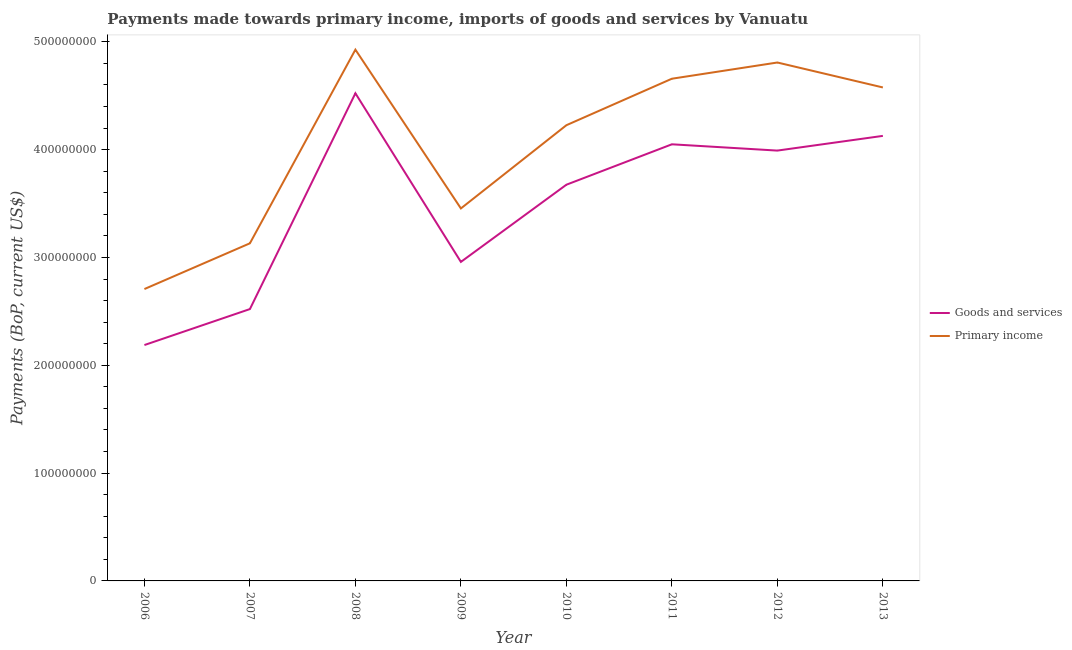Does the line corresponding to payments made towards primary income intersect with the line corresponding to payments made towards goods and services?
Offer a very short reply. No. Is the number of lines equal to the number of legend labels?
Your answer should be very brief. Yes. What is the payments made towards goods and services in 2010?
Ensure brevity in your answer.  3.68e+08. Across all years, what is the maximum payments made towards goods and services?
Make the answer very short. 4.52e+08. Across all years, what is the minimum payments made towards goods and services?
Give a very brief answer. 2.19e+08. In which year was the payments made towards goods and services maximum?
Your response must be concise. 2008. What is the total payments made towards goods and services in the graph?
Offer a very short reply. 2.80e+09. What is the difference between the payments made towards primary income in 2012 and that in 2013?
Offer a very short reply. 2.31e+07. What is the difference between the payments made towards goods and services in 2009 and the payments made towards primary income in 2010?
Provide a short and direct response. -1.27e+08. What is the average payments made towards goods and services per year?
Your response must be concise. 3.50e+08. In the year 2008, what is the difference between the payments made towards goods and services and payments made towards primary income?
Keep it short and to the point. -4.05e+07. In how many years, is the payments made towards goods and services greater than 80000000 US$?
Make the answer very short. 8. What is the ratio of the payments made towards primary income in 2008 to that in 2012?
Ensure brevity in your answer.  1.02. Is the payments made towards primary income in 2010 less than that in 2011?
Your answer should be compact. Yes. What is the difference between the highest and the second highest payments made towards primary income?
Offer a terse response. 1.19e+07. What is the difference between the highest and the lowest payments made towards goods and services?
Ensure brevity in your answer.  2.34e+08. Is the sum of the payments made towards goods and services in 2006 and 2013 greater than the maximum payments made towards primary income across all years?
Your response must be concise. Yes. Does the payments made towards primary income monotonically increase over the years?
Provide a short and direct response. No. Is the payments made towards primary income strictly greater than the payments made towards goods and services over the years?
Your answer should be compact. Yes. Are the values on the major ticks of Y-axis written in scientific E-notation?
Give a very brief answer. No. Where does the legend appear in the graph?
Ensure brevity in your answer.  Center right. How are the legend labels stacked?
Provide a succinct answer. Vertical. What is the title of the graph?
Offer a terse response. Payments made towards primary income, imports of goods and services by Vanuatu. What is the label or title of the X-axis?
Provide a short and direct response. Year. What is the label or title of the Y-axis?
Provide a short and direct response. Payments (BoP, current US$). What is the Payments (BoP, current US$) of Goods and services in 2006?
Make the answer very short. 2.19e+08. What is the Payments (BoP, current US$) in Primary income in 2006?
Make the answer very short. 2.71e+08. What is the Payments (BoP, current US$) of Goods and services in 2007?
Provide a succinct answer. 2.52e+08. What is the Payments (BoP, current US$) in Primary income in 2007?
Your answer should be compact. 3.13e+08. What is the Payments (BoP, current US$) of Goods and services in 2008?
Provide a succinct answer. 4.52e+08. What is the Payments (BoP, current US$) of Primary income in 2008?
Provide a succinct answer. 4.93e+08. What is the Payments (BoP, current US$) of Goods and services in 2009?
Provide a short and direct response. 2.96e+08. What is the Payments (BoP, current US$) of Primary income in 2009?
Ensure brevity in your answer.  3.45e+08. What is the Payments (BoP, current US$) of Goods and services in 2010?
Your answer should be very brief. 3.68e+08. What is the Payments (BoP, current US$) of Primary income in 2010?
Provide a succinct answer. 4.23e+08. What is the Payments (BoP, current US$) in Goods and services in 2011?
Your answer should be compact. 4.05e+08. What is the Payments (BoP, current US$) of Primary income in 2011?
Your answer should be compact. 4.66e+08. What is the Payments (BoP, current US$) of Goods and services in 2012?
Provide a short and direct response. 3.99e+08. What is the Payments (BoP, current US$) in Primary income in 2012?
Provide a succinct answer. 4.81e+08. What is the Payments (BoP, current US$) in Goods and services in 2013?
Provide a succinct answer. 4.13e+08. What is the Payments (BoP, current US$) of Primary income in 2013?
Provide a short and direct response. 4.58e+08. Across all years, what is the maximum Payments (BoP, current US$) in Goods and services?
Give a very brief answer. 4.52e+08. Across all years, what is the maximum Payments (BoP, current US$) of Primary income?
Give a very brief answer. 4.93e+08. Across all years, what is the minimum Payments (BoP, current US$) of Goods and services?
Keep it short and to the point. 2.19e+08. Across all years, what is the minimum Payments (BoP, current US$) in Primary income?
Provide a succinct answer. 2.71e+08. What is the total Payments (BoP, current US$) in Goods and services in the graph?
Keep it short and to the point. 2.80e+09. What is the total Payments (BoP, current US$) of Primary income in the graph?
Offer a very short reply. 3.25e+09. What is the difference between the Payments (BoP, current US$) of Goods and services in 2006 and that in 2007?
Provide a succinct answer. -3.34e+07. What is the difference between the Payments (BoP, current US$) of Primary income in 2006 and that in 2007?
Make the answer very short. -4.24e+07. What is the difference between the Payments (BoP, current US$) of Goods and services in 2006 and that in 2008?
Offer a terse response. -2.34e+08. What is the difference between the Payments (BoP, current US$) of Primary income in 2006 and that in 2008?
Keep it short and to the point. -2.22e+08. What is the difference between the Payments (BoP, current US$) in Goods and services in 2006 and that in 2009?
Your response must be concise. -7.71e+07. What is the difference between the Payments (BoP, current US$) of Primary income in 2006 and that in 2009?
Give a very brief answer. -7.48e+07. What is the difference between the Payments (BoP, current US$) in Goods and services in 2006 and that in 2010?
Give a very brief answer. -1.49e+08. What is the difference between the Payments (BoP, current US$) in Primary income in 2006 and that in 2010?
Your answer should be very brief. -1.52e+08. What is the difference between the Payments (BoP, current US$) of Goods and services in 2006 and that in 2011?
Ensure brevity in your answer.  -1.86e+08. What is the difference between the Payments (BoP, current US$) of Primary income in 2006 and that in 2011?
Ensure brevity in your answer.  -1.95e+08. What is the difference between the Payments (BoP, current US$) in Goods and services in 2006 and that in 2012?
Your answer should be compact. -1.80e+08. What is the difference between the Payments (BoP, current US$) of Primary income in 2006 and that in 2012?
Offer a terse response. -2.10e+08. What is the difference between the Payments (BoP, current US$) in Goods and services in 2006 and that in 2013?
Make the answer very short. -1.94e+08. What is the difference between the Payments (BoP, current US$) in Primary income in 2006 and that in 2013?
Your response must be concise. -1.87e+08. What is the difference between the Payments (BoP, current US$) in Goods and services in 2007 and that in 2008?
Ensure brevity in your answer.  -2.00e+08. What is the difference between the Payments (BoP, current US$) of Primary income in 2007 and that in 2008?
Ensure brevity in your answer.  -1.80e+08. What is the difference between the Payments (BoP, current US$) of Goods and services in 2007 and that in 2009?
Your answer should be compact. -4.38e+07. What is the difference between the Payments (BoP, current US$) in Primary income in 2007 and that in 2009?
Provide a short and direct response. -3.23e+07. What is the difference between the Payments (BoP, current US$) in Goods and services in 2007 and that in 2010?
Give a very brief answer. -1.15e+08. What is the difference between the Payments (BoP, current US$) of Primary income in 2007 and that in 2010?
Give a very brief answer. -1.10e+08. What is the difference between the Payments (BoP, current US$) in Goods and services in 2007 and that in 2011?
Keep it short and to the point. -1.53e+08. What is the difference between the Payments (BoP, current US$) in Primary income in 2007 and that in 2011?
Provide a short and direct response. -1.53e+08. What is the difference between the Payments (BoP, current US$) in Goods and services in 2007 and that in 2012?
Provide a short and direct response. -1.47e+08. What is the difference between the Payments (BoP, current US$) of Primary income in 2007 and that in 2012?
Your response must be concise. -1.68e+08. What is the difference between the Payments (BoP, current US$) of Goods and services in 2007 and that in 2013?
Provide a succinct answer. -1.61e+08. What is the difference between the Payments (BoP, current US$) in Primary income in 2007 and that in 2013?
Provide a short and direct response. -1.45e+08. What is the difference between the Payments (BoP, current US$) of Goods and services in 2008 and that in 2009?
Your answer should be compact. 1.56e+08. What is the difference between the Payments (BoP, current US$) of Primary income in 2008 and that in 2009?
Offer a very short reply. 1.47e+08. What is the difference between the Payments (BoP, current US$) of Goods and services in 2008 and that in 2010?
Ensure brevity in your answer.  8.48e+07. What is the difference between the Payments (BoP, current US$) in Primary income in 2008 and that in 2010?
Offer a terse response. 7.01e+07. What is the difference between the Payments (BoP, current US$) in Goods and services in 2008 and that in 2011?
Give a very brief answer. 4.73e+07. What is the difference between the Payments (BoP, current US$) of Primary income in 2008 and that in 2011?
Provide a succinct answer. 2.70e+07. What is the difference between the Payments (BoP, current US$) in Goods and services in 2008 and that in 2012?
Your response must be concise. 5.32e+07. What is the difference between the Payments (BoP, current US$) in Primary income in 2008 and that in 2012?
Offer a terse response. 1.19e+07. What is the difference between the Payments (BoP, current US$) of Goods and services in 2008 and that in 2013?
Keep it short and to the point. 3.95e+07. What is the difference between the Payments (BoP, current US$) of Primary income in 2008 and that in 2013?
Provide a succinct answer. 3.51e+07. What is the difference between the Payments (BoP, current US$) of Goods and services in 2009 and that in 2010?
Give a very brief answer. -7.16e+07. What is the difference between the Payments (BoP, current US$) in Primary income in 2009 and that in 2010?
Your answer should be compact. -7.72e+07. What is the difference between the Payments (BoP, current US$) in Goods and services in 2009 and that in 2011?
Your answer should be very brief. -1.09e+08. What is the difference between the Payments (BoP, current US$) of Primary income in 2009 and that in 2011?
Provide a succinct answer. -1.20e+08. What is the difference between the Payments (BoP, current US$) in Goods and services in 2009 and that in 2012?
Provide a succinct answer. -1.03e+08. What is the difference between the Payments (BoP, current US$) of Primary income in 2009 and that in 2012?
Make the answer very short. -1.35e+08. What is the difference between the Payments (BoP, current US$) in Goods and services in 2009 and that in 2013?
Offer a terse response. -1.17e+08. What is the difference between the Payments (BoP, current US$) in Primary income in 2009 and that in 2013?
Your answer should be very brief. -1.12e+08. What is the difference between the Payments (BoP, current US$) in Goods and services in 2010 and that in 2011?
Ensure brevity in your answer.  -3.75e+07. What is the difference between the Payments (BoP, current US$) in Primary income in 2010 and that in 2011?
Keep it short and to the point. -4.31e+07. What is the difference between the Payments (BoP, current US$) in Goods and services in 2010 and that in 2012?
Give a very brief answer. -3.17e+07. What is the difference between the Payments (BoP, current US$) in Primary income in 2010 and that in 2012?
Keep it short and to the point. -5.82e+07. What is the difference between the Payments (BoP, current US$) in Goods and services in 2010 and that in 2013?
Your response must be concise. -4.53e+07. What is the difference between the Payments (BoP, current US$) of Primary income in 2010 and that in 2013?
Keep it short and to the point. -3.50e+07. What is the difference between the Payments (BoP, current US$) of Goods and services in 2011 and that in 2012?
Your answer should be compact. 5.84e+06. What is the difference between the Payments (BoP, current US$) in Primary income in 2011 and that in 2012?
Give a very brief answer. -1.50e+07. What is the difference between the Payments (BoP, current US$) of Goods and services in 2011 and that in 2013?
Your answer should be very brief. -7.81e+06. What is the difference between the Payments (BoP, current US$) in Primary income in 2011 and that in 2013?
Your answer should be very brief. 8.10e+06. What is the difference between the Payments (BoP, current US$) of Goods and services in 2012 and that in 2013?
Your response must be concise. -1.36e+07. What is the difference between the Payments (BoP, current US$) of Primary income in 2012 and that in 2013?
Keep it short and to the point. 2.31e+07. What is the difference between the Payments (BoP, current US$) of Goods and services in 2006 and the Payments (BoP, current US$) of Primary income in 2007?
Your answer should be compact. -9.44e+07. What is the difference between the Payments (BoP, current US$) of Goods and services in 2006 and the Payments (BoP, current US$) of Primary income in 2008?
Keep it short and to the point. -2.74e+08. What is the difference between the Payments (BoP, current US$) of Goods and services in 2006 and the Payments (BoP, current US$) of Primary income in 2009?
Keep it short and to the point. -1.27e+08. What is the difference between the Payments (BoP, current US$) of Goods and services in 2006 and the Payments (BoP, current US$) of Primary income in 2010?
Keep it short and to the point. -2.04e+08. What is the difference between the Payments (BoP, current US$) of Goods and services in 2006 and the Payments (BoP, current US$) of Primary income in 2011?
Ensure brevity in your answer.  -2.47e+08. What is the difference between the Payments (BoP, current US$) in Goods and services in 2006 and the Payments (BoP, current US$) in Primary income in 2012?
Your answer should be very brief. -2.62e+08. What is the difference between the Payments (BoP, current US$) in Goods and services in 2006 and the Payments (BoP, current US$) in Primary income in 2013?
Offer a terse response. -2.39e+08. What is the difference between the Payments (BoP, current US$) of Goods and services in 2007 and the Payments (BoP, current US$) of Primary income in 2008?
Give a very brief answer. -2.41e+08. What is the difference between the Payments (BoP, current US$) of Goods and services in 2007 and the Payments (BoP, current US$) of Primary income in 2009?
Keep it short and to the point. -9.33e+07. What is the difference between the Payments (BoP, current US$) of Goods and services in 2007 and the Payments (BoP, current US$) of Primary income in 2010?
Your response must be concise. -1.71e+08. What is the difference between the Payments (BoP, current US$) in Goods and services in 2007 and the Payments (BoP, current US$) in Primary income in 2011?
Give a very brief answer. -2.14e+08. What is the difference between the Payments (BoP, current US$) in Goods and services in 2007 and the Payments (BoP, current US$) in Primary income in 2012?
Your answer should be compact. -2.29e+08. What is the difference between the Payments (BoP, current US$) in Goods and services in 2007 and the Payments (BoP, current US$) in Primary income in 2013?
Ensure brevity in your answer.  -2.06e+08. What is the difference between the Payments (BoP, current US$) of Goods and services in 2008 and the Payments (BoP, current US$) of Primary income in 2009?
Your answer should be very brief. 1.07e+08. What is the difference between the Payments (BoP, current US$) of Goods and services in 2008 and the Payments (BoP, current US$) of Primary income in 2010?
Give a very brief answer. 2.96e+07. What is the difference between the Payments (BoP, current US$) of Goods and services in 2008 and the Payments (BoP, current US$) of Primary income in 2011?
Keep it short and to the point. -1.35e+07. What is the difference between the Payments (BoP, current US$) in Goods and services in 2008 and the Payments (BoP, current US$) in Primary income in 2012?
Provide a succinct answer. -2.85e+07. What is the difference between the Payments (BoP, current US$) in Goods and services in 2008 and the Payments (BoP, current US$) in Primary income in 2013?
Offer a very short reply. -5.40e+06. What is the difference between the Payments (BoP, current US$) in Goods and services in 2009 and the Payments (BoP, current US$) in Primary income in 2010?
Make the answer very short. -1.27e+08. What is the difference between the Payments (BoP, current US$) in Goods and services in 2009 and the Payments (BoP, current US$) in Primary income in 2011?
Give a very brief answer. -1.70e+08. What is the difference between the Payments (BoP, current US$) of Goods and services in 2009 and the Payments (BoP, current US$) of Primary income in 2012?
Keep it short and to the point. -1.85e+08. What is the difference between the Payments (BoP, current US$) in Goods and services in 2009 and the Payments (BoP, current US$) in Primary income in 2013?
Give a very brief answer. -1.62e+08. What is the difference between the Payments (BoP, current US$) of Goods and services in 2010 and the Payments (BoP, current US$) of Primary income in 2011?
Keep it short and to the point. -9.83e+07. What is the difference between the Payments (BoP, current US$) of Goods and services in 2010 and the Payments (BoP, current US$) of Primary income in 2012?
Your response must be concise. -1.13e+08. What is the difference between the Payments (BoP, current US$) in Goods and services in 2010 and the Payments (BoP, current US$) in Primary income in 2013?
Your answer should be very brief. -9.02e+07. What is the difference between the Payments (BoP, current US$) in Goods and services in 2011 and the Payments (BoP, current US$) in Primary income in 2012?
Ensure brevity in your answer.  -7.59e+07. What is the difference between the Payments (BoP, current US$) in Goods and services in 2011 and the Payments (BoP, current US$) in Primary income in 2013?
Offer a very short reply. -5.27e+07. What is the difference between the Payments (BoP, current US$) of Goods and services in 2012 and the Payments (BoP, current US$) of Primary income in 2013?
Your response must be concise. -5.86e+07. What is the average Payments (BoP, current US$) of Goods and services per year?
Make the answer very short. 3.50e+08. What is the average Payments (BoP, current US$) in Primary income per year?
Your answer should be compact. 4.06e+08. In the year 2006, what is the difference between the Payments (BoP, current US$) of Goods and services and Payments (BoP, current US$) of Primary income?
Give a very brief answer. -5.19e+07. In the year 2007, what is the difference between the Payments (BoP, current US$) in Goods and services and Payments (BoP, current US$) in Primary income?
Provide a succinct answer. -6.10e+07. In the year 2008, what is the difference between the Payments (BoP, current US$) in Goods and services and Payments (BoP, current US$) in Primary income?
Your answer should be very brief. -4.05e+07. In the year 2009, what is the difference between the Payments (BoP, current US$) of Goods and services and Payments (BoP, current US$) of Primary income?
Offer a terse response. -4.96e+07. In the year 2010, what is the difference between the Payments (BoP, current US$) of Goods and services and Payments (BoP, current US$) of Primary income?
Your answer should be very brief. -5.52e+07. In the year 2011, what is the difference between the Payments (BoP, current US$) of Goods and services and Payments (BoP, current US$) of Primary income?
Give a very brief answer. -6.08e+07. In the year 2012, what is the difference between the Payments (BoP, current US$) of Goods and services and Payments (BoP, current US$) of Primary income?
Provide a succinct answer. -8.17e+07. In the year 2013, what is the difference between the Payments (BoP, current US$) of Goods and services and Payments (BoP, current US$) of Primary income?
Provide a succinct answer. -4.49e+07. What is the ratio of the Payments (BoP, current US$) in Goods and services in 2006 to that in 2007?
Offer a very short reply. 0.87. What is the ratio of the Payments (BoP, current US$) of Primary income in 2006 to that in 2007?
Offer a very short reply. 0.86. What is the ratio of the Payments (BoP, current US$) in Goods and services in 2006 to that in 2008?
Provide a succinct answer. 0.48. What is the ratio of the Payments (BoP, current US$) of Primary income in 2006 to that in 2008?
Your answer should be compact. 0.55. What is the ratio of the Payments (BoP, current US$) in Goods and services in 2006 to that in 2009?
Offer a very short reply. 0.74. What is the ratio of the Payments (BoP, current US$) of Primary income in 2006 to that in 2009?
Ensure brevity in your answer.  0.78. What is the ratio of the Payments (BoP, current US$) in Goods and services in 2006 to that in 2010?
Give a very brief answer. 0.6. What is the ratio of the Payments (BoP, current US$) in Primary income in 2006 to that in 2010?
Your answer should be compact. 0.64. What is the ratio of the Payments (BoP, current US$) in Goods and services in 2006 to that in 2011?
Your answer should be compact. 0.54. What is the ratio of the Payments (BoP, current US$) in Primary income in 2006 to that in 2011?
Your answer should be very brief. 0.58. What is the ratio of the Payments (BoP, current US$) in Goods and services in 2006 to that in 2012?
Make the answer very short. 0.55. What is the ratio of the Payments (BoP, current US$) of Primary income in 2006 to that in 2012?
Provide a short and direct response. 0.56. What is the ratio of the Payments (BoP, current US$) of Goods and services in 2006 to that in 2013?
Ensure brevity in your answer.  0.53. What is the ratio of the Payments (BoP, current US$) of Primary income in 2006 to that in 2013?
Your answer should be compact. 0.59. What is the ratio of the Payments (BoP, current US$) of Goods and services in 2007 to that in 2008?
Offer a very short reply. 0.56. What is the ratio of the Payments (BoP, current US$) in Primary income in 2007 to that in 2008?
Make the answer very short. 0.64. What is the ratio of the Payments (BoP, current US$) in Goods and services in 2007 to that in 2009?
Provide a short and direct response. 0.85. What is the ratio of the Payments (BoP, current US$) of Primary income in 2007 to that in 2009?
Your answer should be very brief. 0.91. What is the ratio of the Payments (BoP, current US$) in Goods and services in 2007 to that in 2010?
Give a very brief answer. 0.69. What is the ratio of the Payments (BoP, current US$) of Primary income in 2007 to that in 2010?
Make the answer very short. 0.74. What is the ratio of the Payments (BoP, current US$) in Goods and services in 2007 to that in 2011?
Your response must be concise. 0.62. What is the ratio of the Payments (BoP, current US$) of Primary income in 2007 to that in 2011?
Make the answer very short. 0.67. What is the ratio of the Payments (BoP, current US$) in Goods and services in 2007 to that in 2012?
Ensure brevity in your answer.  0.63. What is the ratio of the Payments (BoP, current US$) of Primary income in 2007 to that in 2012?
Your answer should be very brief. 0.65. What is the ratio of the Payments (BoP, current US$) in Goods and services in 2007 to that in 2013?
Your answer should be compact. 0.61. What is the ratio of the Payments (BoP, current US$) in Primary income in 2007 to that in 2013?
Your answer should be very brief. 0.68. What is the ratio of the Payments (BoP, current US$) in Goods and services in 2008 to that in 2009?
Offer a very short reply. 1.53. What is the ratio of the Payments (BoP, current US$) of Primary income in 2008 to that in 2009?
Keep it short and to the point. 1.43. What is the ratio of the Payments (BoP, current US$) in Goods and services in 2008 to that in 2010?
Your answer should be compact. 1.23. What is the ratio of the Payments (BoP, current US$) in Primary income in 2008 to that in 2010?
Provide a short and direct response. 1.17. What is the ratio of the Payments (BoP, current US$) of Goods and services in 2008 to that in 2011?
Offer a terse response. 1.12. What is the ratio of the Payments (BoP, current US$) in Primary income in 2008 to that in 2011?
Your response must be concise. 1.06. What is the ratio of the Payments (BoP, current US$) in Goods and services in 2008 to that in 2012?
Offer a terse response. 1.13. What is the ratio of the Payments (BoP, current US$) of Primary income in 2008 to that in 2012?
Your response must be concise. 1.02. What is the ratio of the Payments (BoP, current US$) in Goods and services in 2008 to that in 2013?
Offer a terse response. 1.1. What is the ratio of the Payments (BoP, current US$) of Primary income in 2008 to that in 2013?
Offer a terse response. 1.08. What is the ratio of the Payments (BoP, current US$) of Goods and services in 2009 to that in 2010?
Make the answer very short. 0.81. What is the ratio of the Payments (BoP, current US$) of Primary income in 2009 to that in 2010?
Your answer should be compact. 0.82. What is the ratio of the Payments (BoP, current US$) in Goods and services in 2009 to that in 2011?
Ensure brevity in your answer.  0.73. What is the ratio of the Payments (BoP, current US$) of Primary income in 2009 to that in 2011?
Your answer should be compact. 0.74. What is the ratio of the Payments (BoP, current US$) in Goods and services in 2009 to that in 2012?
Your answer should be compact. 0.74. What is the ratio of the Payments (BoP, current US$) in Primary income in 2009 to that in 2012?
Your answer should be compact. 0.72. What is the ratio of the Payments (BoP, current US$) of Goods and services in 2009 to that in 2013?
Provide a succinct answer. 0.72. What is the ratio of the Payments (BoP, current US$) in Primary income in 2009 to that in 2013?
Offer a very short reply. 0.75. What is the ratio of the Payments (BoP, current US$) in Goods and services in 2010 to that in 2011?
Offer a very short reply. 0.91. What is the ratio of the Payments (BoP, current US$) of Primary income in 2010 to that in 2011?
Offer a very short reply. 0.91. What is the ratio of the Payments (BoP, current US$) in Goods and services in 2010 to that in 2012?
Your answer should be compact. 0.92. What is the ratio of the Payments (BoP, current US$) in Primary income in 2010 to that in 2012?
Offer a very short reply. 0.88. What is the ratio of the Payments (BoP, current US$) of Goods and services in 2010 to that in 2013?
Make the answer very short. 0.89. What is the ratio of the Payments (BoP, current US$) in Primary income in 2010 to that in 2013?
Make the answer very short. 0.92. What is the ratio of the Payments (BoP, current US$) of Goods and services in 2011 to that in 2012?
Provide a short and direct response. 1.01. What is the ratio of the Payments (BoP, current US$) in Primary income in 2011 to that in 2012?
Provide a succinct answer. 0.97. What is the ratio of the Payments (BoP, current US$) in Goods and services in 2011 to that in 2013?
Ensure brevity in your answer.  0.98. What is the ratio of the Payments (BoP, current US$) in Primary income in 2011 to that in 2013?
Your response must be concise. 1.02. What is the ratio of the Payments (BoP, current US$) in Goods and services in 2012 to that in 2013?
Provide a succinct answer. 0.97. What is the ratio of the Payments (BoP, current US$) of Primary income in 2012 to that in 2013?
Your answer should be compact. 1.05. What is the difference between the highest and the second highest Payments (BoP, current US$) in Goods and services?
Make the answer very short. 3.95e+07. What is the difference between the highest and the second highest Payments (BoP, current US$) of Primary income?
Offer a terse response. 1.19e+07. What is the difference between the highest and the lowest Payments (BoP, current US$) in Goods and services?
Ensure brevity in your answer.  2.34e+08. What is the difference between the highest and the lowest Payments (BoP, current US$) of Primary income?
Provide a short and direct response. 2.22e+08. 